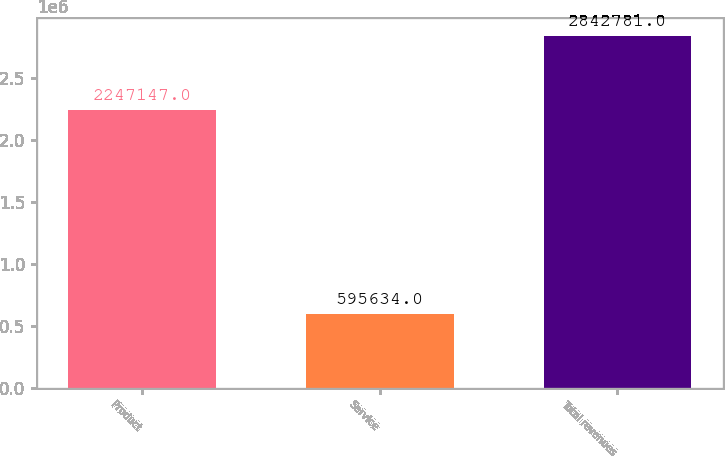Convert chart to OTSL. <chart><loc_0><loc_0><loc_500><loc_500><bar_chart><fcel>Product<fcel>Service<fcel>Total revenues<nl><fcel>2.24715e+06<fcel>595634<fcel>2.84278e+06<nl></chart> 